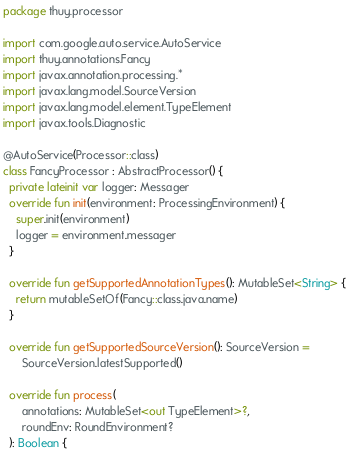<code> <loc_0><loc_0><loc_500><loc_500><_Kotlin_>package thuy.processor

import com.google.auto.service.AutoService
import thuy.annotations.Fancy
import javax.annotation.processing.*
import javax.lang.model.SourceVersion
import javax.lang.model.element.TypeElement
import javax.tools.Diagnostic

@AutoService(Processor::class)
class FancyProcessor : AbstractProcessor() {
  private lateinit var logger: Messager
  override fun init(environment: ProcessingEnvironment) {
    super.init(environment)
    logger = environment.messager
  }

  override fun getSupportedAnnotationTypes(): MutableSet<String> {
    return mutableSetOf(Fancy::class.java.name)
  }

  override fun getSupportedSourceVersion(): SourceVersion =
      SourceVersion.latestSupported()

  override fun process(
      annotations: MutableSet<out TypeElement>?,
      roundEnv: RoundEnvironment?
  ): Boolean {</code> 